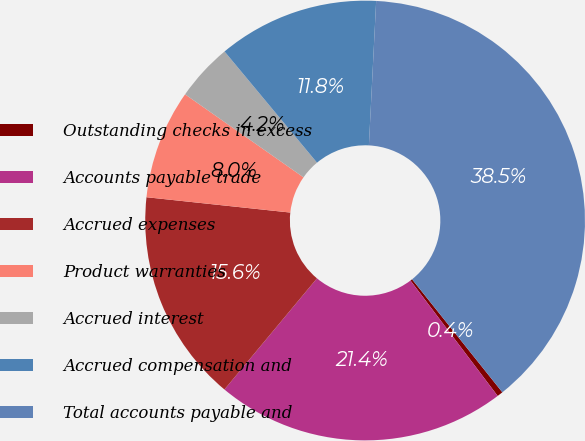Convert chart. <chart><loc_0><loc_0><loc_500><loc_500><pie_chart><fcel>Outstanding checks in excess<fcel>Accounts payable trade<fcel>Accrued expenses<fcel>Product warranties<fcel>Accrued interest<fcel>Accrued compensation and<fcel>Total accounts payable and<nl><fcel>0.43%<fcel>21.35%<fcel>15.64%<fcel>8.04%<fcel>4.23%<fcel>11.84%<fcel>38.47%<nl></chart> 